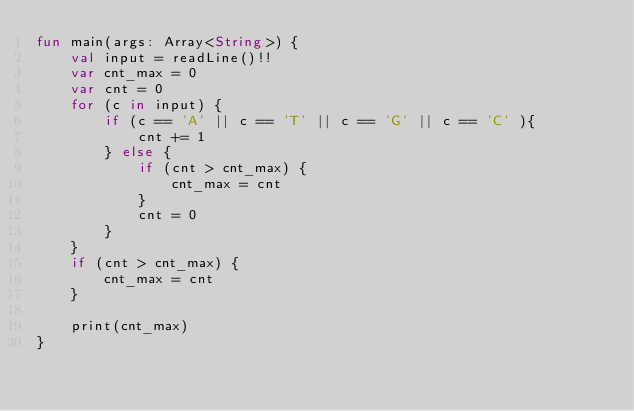Convert code to text. <code><loc_0><loc_0><loc_500><loc_500><_Kotlin_>fun main(args: Array<String>) {
    val input = readLine()!!
    var cnt_max = 0
    var cnt = 0
    for (c in input) {
        if (c == 'A' || c == 'T' || c == 'G' || c == 'C' ){
            cnt += 1
        } else {
            if (cnt > cnt_max) {
                cnt_max = cnt
            }
            cnt = 0
        }
    }
    if (cnt > cnt_max) {
        cnt_max = cnt
    }

    print(cnt_max)
}</code> 